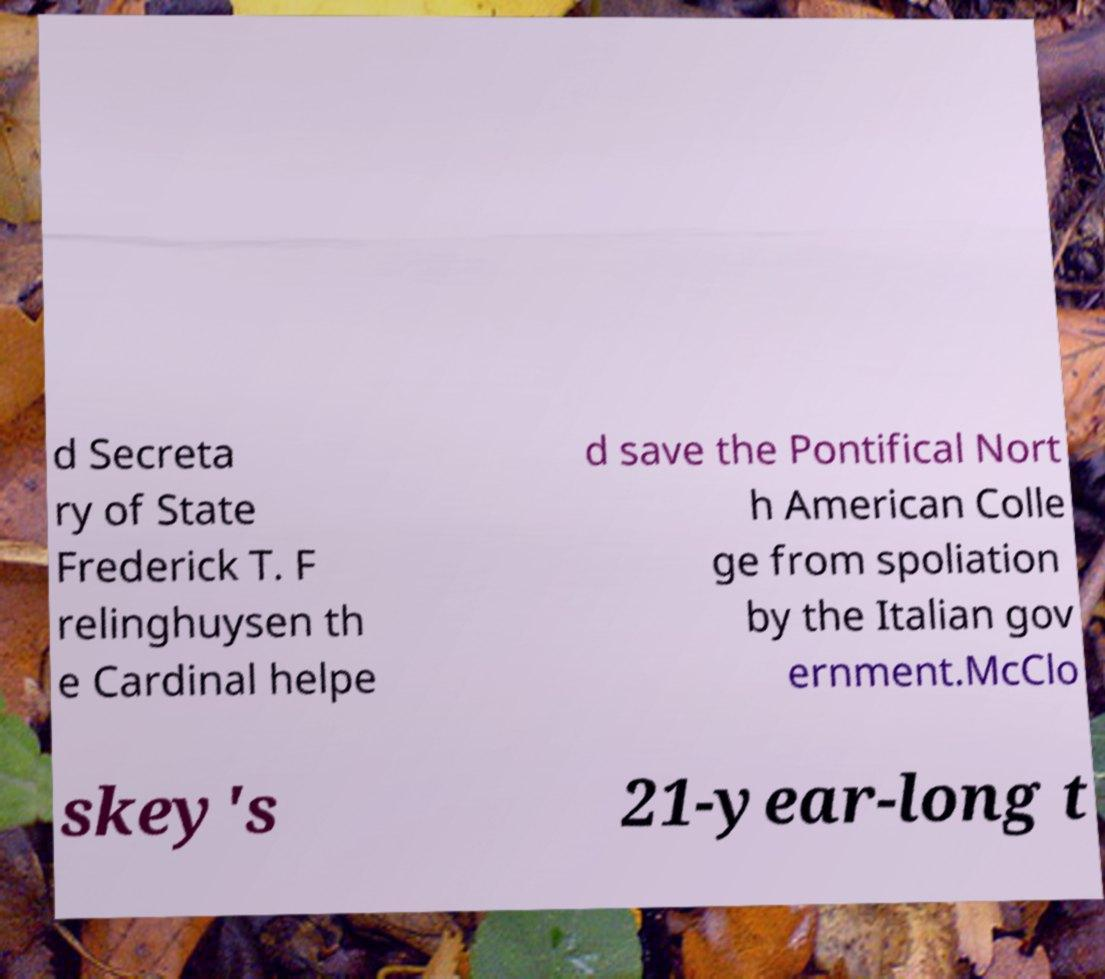Could you assist in decoding the text presented in this image and type it out clearly? d Secreta ry of State Frederick T. F relinghuysen th e Cardinal helpe d save the Pontifical Nort h American Colle ge from spoliation by the Italian gov ernment.McClo skey's 21-year-long t 